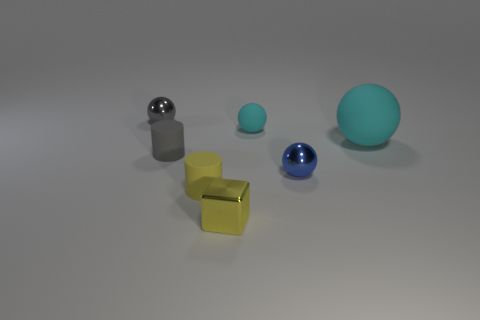What time of day or lighting situation does the environment suggest? The lighting in the image gives the impression of a controlled, indoor space with a neutral, possibly artificial light source. It's diffused evenly, lacking harsh shadows or indications of a strong directional light, such as sunlight. 